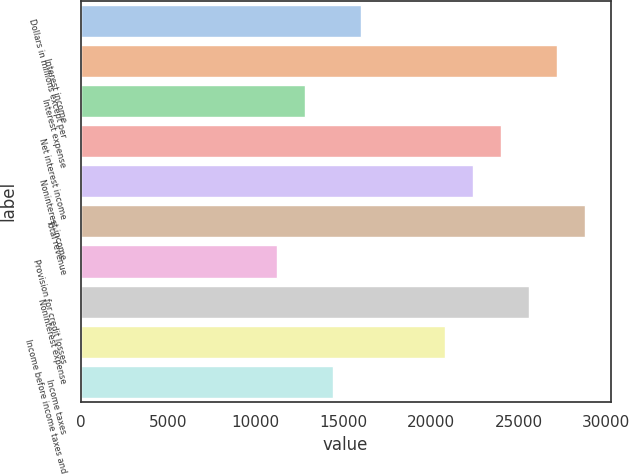<chart> <loc_0><loc_0><loc_500><loc_500><bar_chart><fcel>Dollars in millions except per<fcel>Interest income<fcel>Interest expense<fcel>Net interest income<fcel>Noninterest income<fcel>Total revenue<fcel>Provision for credit losses<fcel>Noninterest expense<fcel>Income before income taxes and<fcel>Income taxes<nl><fcel>16012<fcel>27219.2<fcel>12810<fcel>24017.2<fcel>22416.1<fcel>28820.3<fcel>11208.9<fcel>25618.2<fcel>20815.1<fcel>14411<nl></chart> 